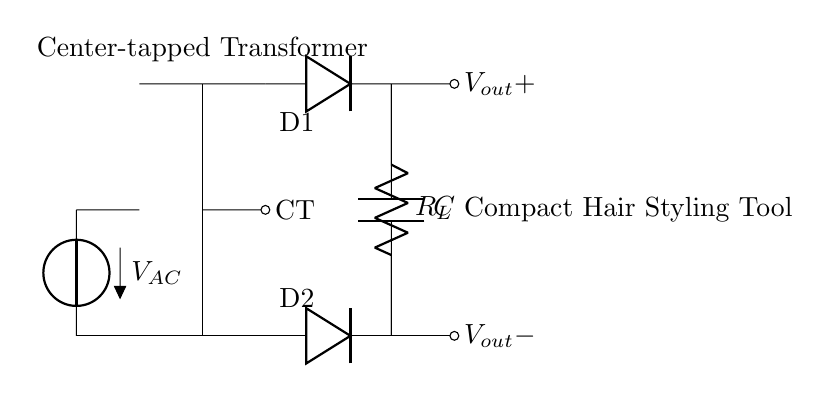What is the type of transformer used in this circuit? The circuit uses a center-tapped transformer, indicated by the notation "CT" and the central tap in the diagram that connects the secondary winding to ground or reference point.
Answer: center-tapped transformer What components are connected to the output? The output connects to a load resistor and a capacitor, which are visible in the diagram where the lines lead to the components labeled as R_L and C.
Answer: load resistor and capacitor How many diodes are in this rectifier circuit? There are two diodes in the circuit, which are represented as D1 and D2, placed in such a way to handle the AC input for rectification.
Answer: two What is the purpose of the capacitor in this circuit? The capacitor serves to smooth the rectified output voltage, reducing ripple, resulting in a more stable direct current for the hair styling tool.
Answer: smoothing the rectified output In which section does the alternating current source appear? The alternating current source is found at the left side of the circuit, labeled as V_AC, connecting to the transformer.
Answer: left side What is the significance of the center tap in this transformer? The center tap provides a ground reference point and allows for the formation of a full-wave rectifier circuit with the two connected diodes, enabling both halves of the AC wave to be utilized.
Answer: ground reference point 